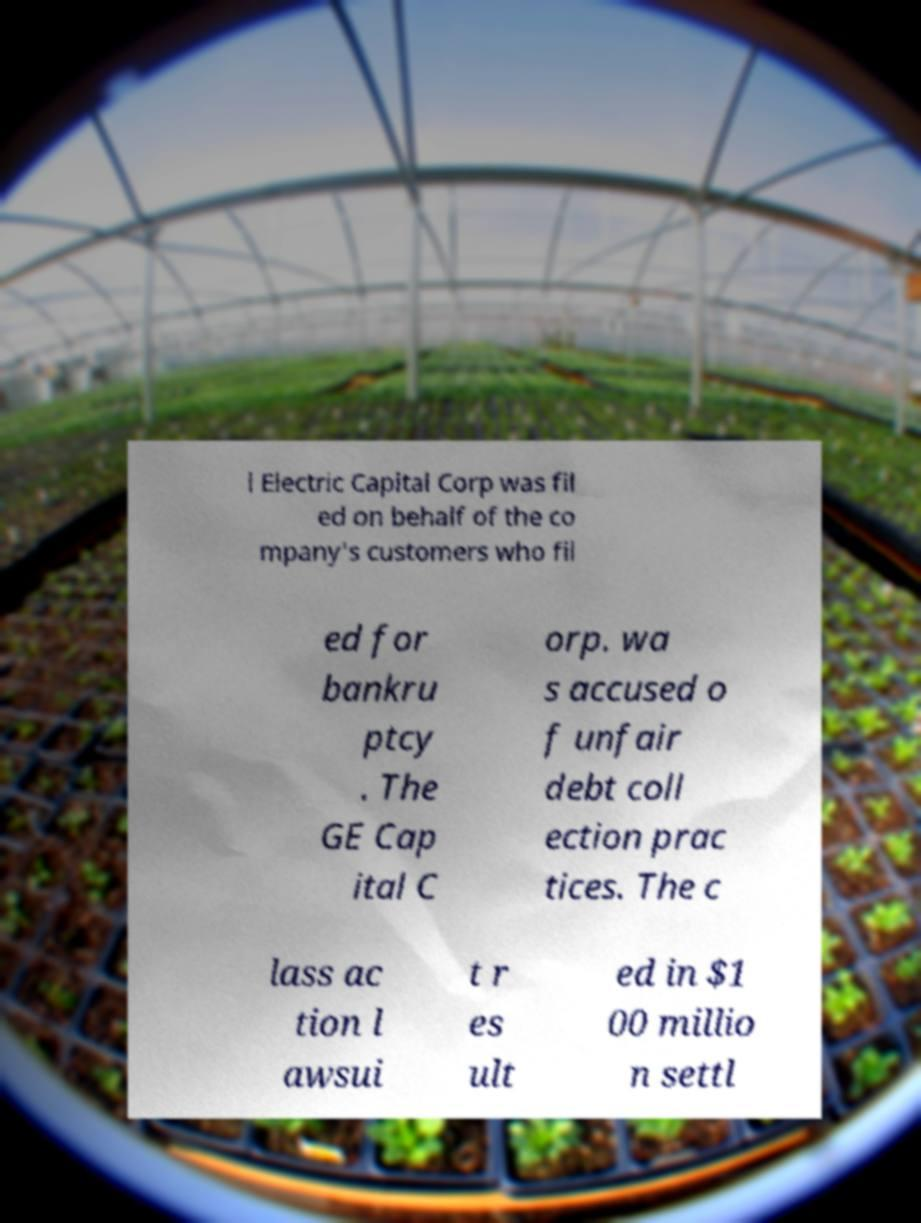Could you extract and type out the text from this image? l Electric Capital Corp was fil ed on behalf of the co mpany's customers who fil ed for bankru ptcy . The GE Cap ital C orp. wa s accused o f unfair debt coll ection prac tices. The c lass ac tion l awsui t r es ult ed in $1 00 millio n settl 